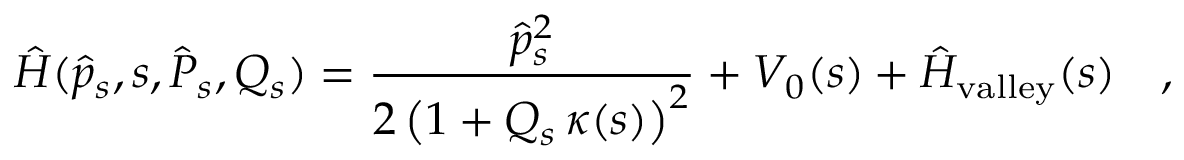Convert formula to latex. <formula><loc_0><loc_0><loc_500><loc_500>\hat { H } ( \hat { p } _ { s } , s , \hat { P } _ { s } , Q _ { s } ) = \frac { \hat { p } _ { s } ^ { 2 } } { 2 \left ( 1 + Q _ { s } \, \kappa ( s ) \right ) ^ { 2 } } + V _ { 0 } ( s ) + \hat { H } _ { v a l l e y } ( s ) \quad ,</formula> 